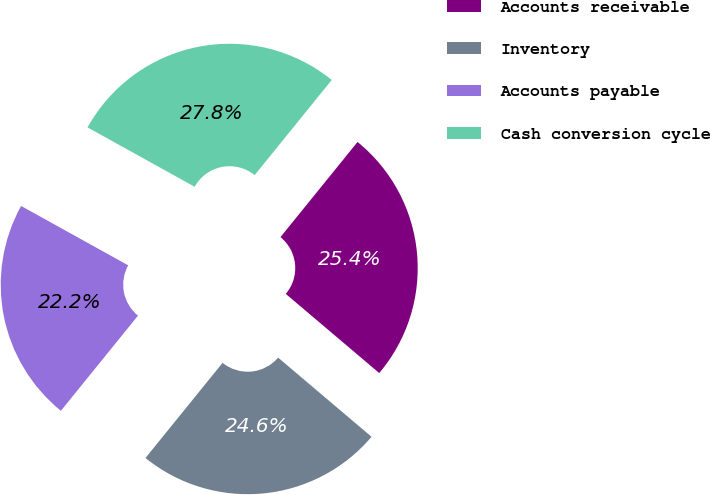Convert chart to OTSL. <chart><loc_0><loc_0><loc_500><loc_500><pie_chart><fcel>Accounts receivable<fcel>Inventory<fcel>Accounts payable<fcel>Cash conversion cycle<nl><fcel>25.35%<fcel>24.65%<fcel>22.22%<fcel>27.78%<nl></chart> 